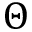Convert formula to latex. <formula><loc_0><loc_0><loc_500><loc_500>\Theta</formula> 